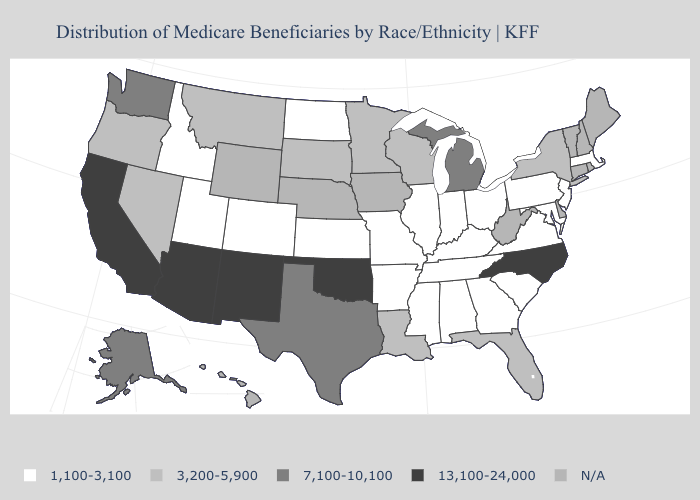Name the states that have a value in the range 1,100-3,100?
Quick response, please. Alabama, Arkansas, Colorado, Georgia, Idaho, Illinois, Indiana, Kansas, Kentucky, Maryland, Massachusetts, Mississippi, Missouri, New Jersey, North Dakota, Ohio, Pennsylvania, South Carolina, Tennessee, Utah, Virginia. Which states have the lowest value in the South?
Concise answer only. Alabama, Arkansas, Georgia, Kentucky, Maryland, Mississippi, South Carolina, Tennessee, Virginia. What is the lowest value in the USA?
Give a very brief answer. 1,100-3,100. What is the value of Pennsylvania?
Keep it brief. 1,100-3,100. Which states have the highest value in the USA?
Write a very short answer. Arizona, California, New Mexico, North Carolina, Oklahoma. What is the highest value in the USA?
Write a very short answer. 13,100-24,000. Does Utah have the lowest value in the West?
Quick response, please. Yes. What is the highest value in the USA?
Be succinct. 13,100-24,000. Name the states that have a value in the range N/A?
Keep it brief. Connecticut, Delaware, Hawaii, Iowa, Maine, Nebraska, New Hampshire, Rhode Island, Vermont, West Virginia, Wyoming. Is the legend a continuous bar?
Be succinct. No. What is the highest value in the Northeast ?
Short answer required. 3,200-5,900. Among the states that border New York , which have the lowest value?
Quick response, please. Massachusetts, New Jersey, Pennsylvania. Name the states that have a value in the range 13,100-24,000?
Short answer required. Arizona, California, New Mexico, North Carolina, Oklahoma. Among the states that border Ohio , which have the lowest value?
Concise answer only. Indiana, Kentucky, Pennsylvania. 